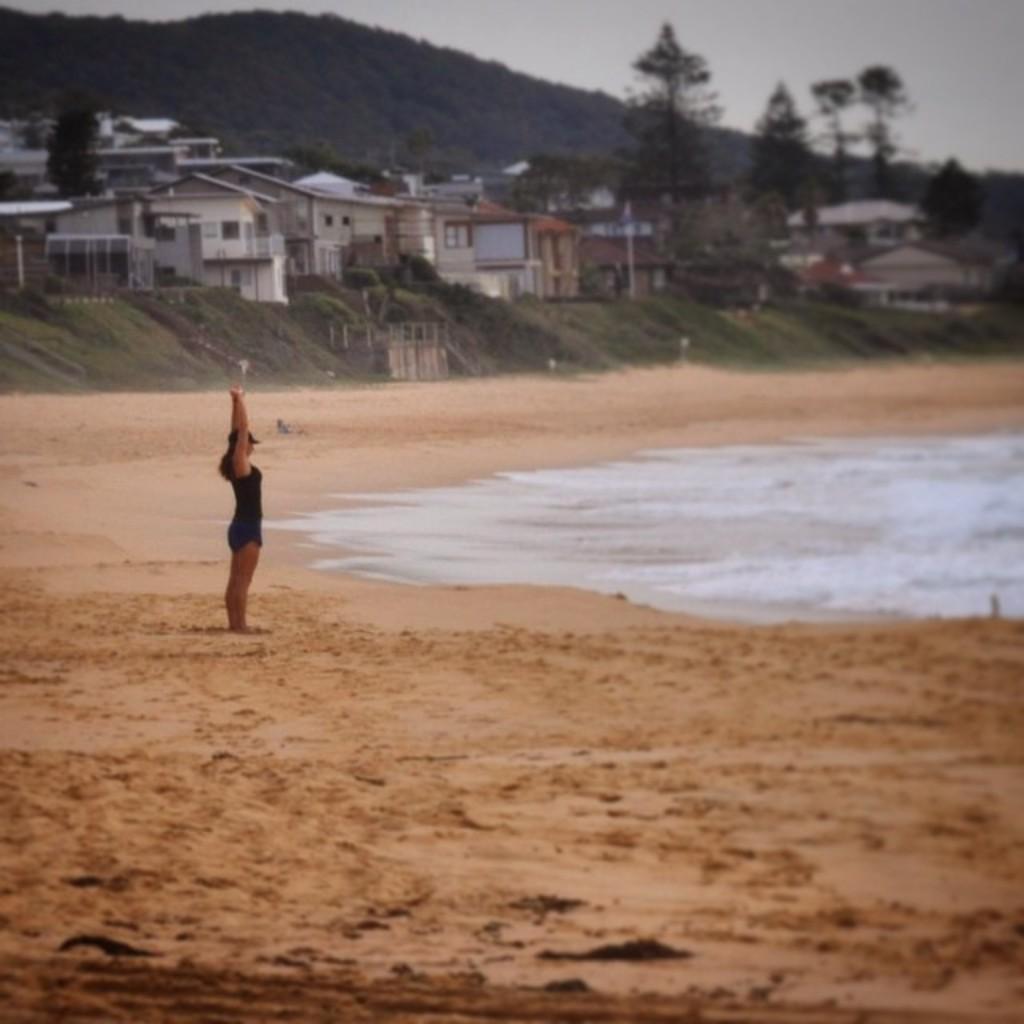In one or two sentences, can you explain what this image depicts? On the left side, there is a woman in a black color dress, stretched her hands up and standing on a sand surface. On the right side, there are tides of the ocean. In the background, there are trees, buildings, a mountain and the sky. 